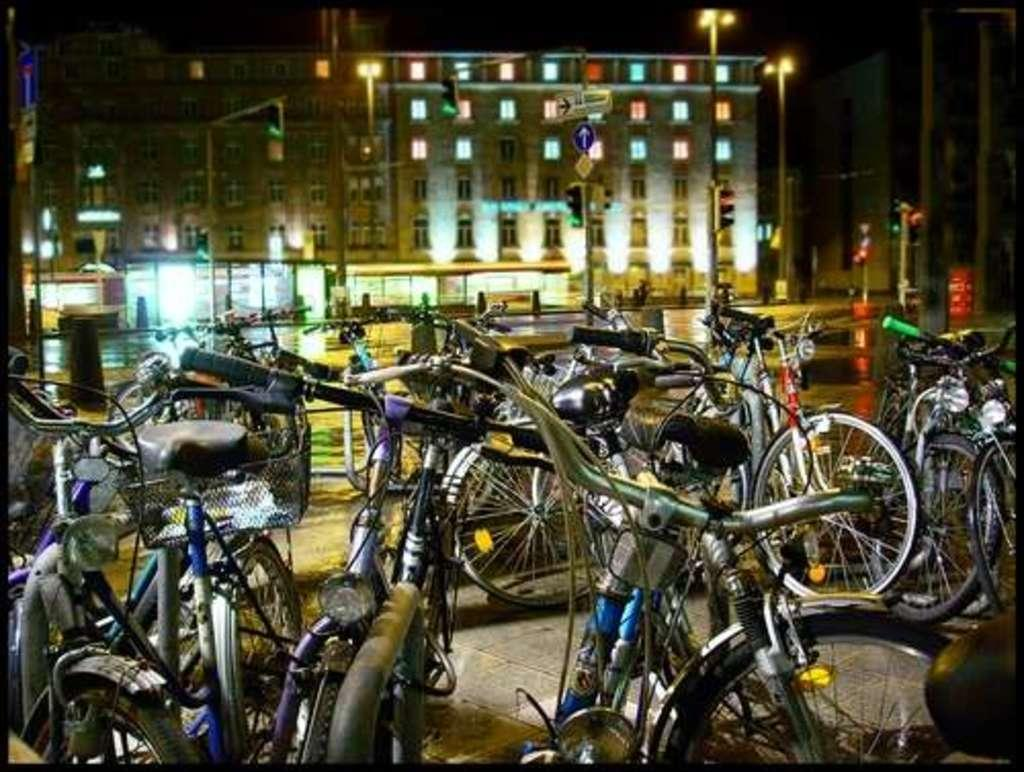What type of vehicles are in the front of the image? There are bicycles in the front of the image. What can be seen in the background of the image? There is a building in the background of the image. What other objects are visible in the image? There are poles and lights visible in the image. Where is the sign board located in the image? The sign board is in the middle of the image. What type of crown is placed on top of the sign board in the image? There is no crown present on the sign board or anywhere else in the image. 